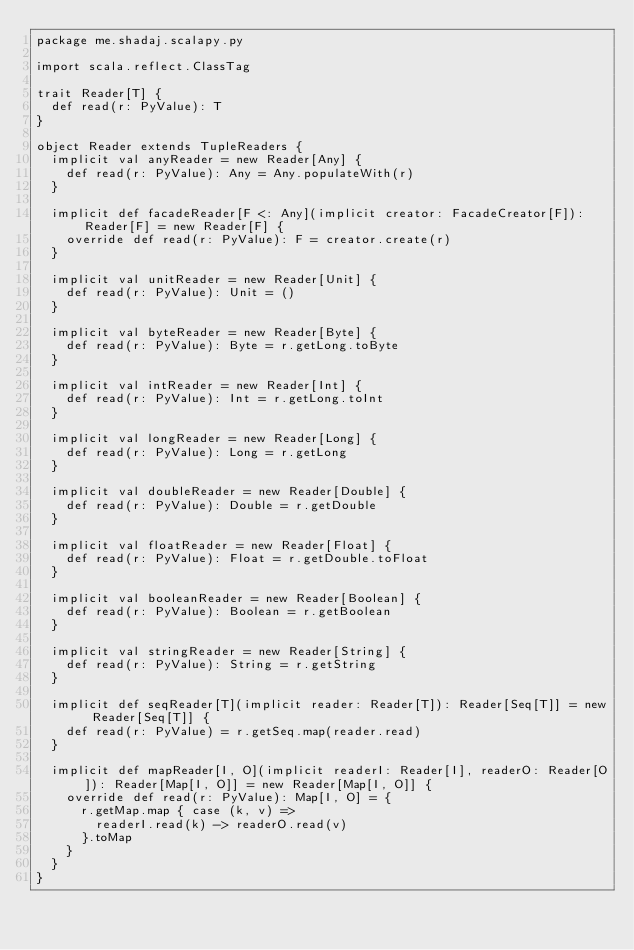<code> <loc_0><loc_0><loc_500><loc_500><_Scala_>package me.shadaj.scalapy.py

import scala.reflect.ClassTag

trait Reader[T] {
  def read(r: PyValue): T
}

object Reader extends TupleReaders {
  implicit val anyReader = new Reader[Any] {
    def read(r: PyValue): Any = Any.populateWith(r)
  }

  implicit def facadeReader[F <: Any](implicit creator: FacadeCreator[F]): Reader[F] = new Reader[F] {
    override def read(r: PyValue): F = creator.create(r)
  }

  implicit val unitReader = new Reader[Unit] {
    def read(r: PyValue): Unit = ()
  }

  implicit val byteReader = new Reader[Byte] {
    def read(r: PyValue): Byte = r.getLong.toByte
  }

  implicit val intReader = new Reader[Int] {
    def read(r: PyValue): Int = r.getLong.toInt
  }

  implicit val longReader = new Reader[Long] {
    def read(r: PyValue): Long = r.getLong
  }

  implicit val doubleReader = new Reader[Double] {
    def read(r: PyValue): Double = r.getDouble
  }

  implicit val floatReader = new Reader[Float] {
    def read(r: PyValue): Float = r.getDouble.toFloat
  }

  implicit val booleanReader = new Reader[Boolean] {
    def read(r: PyValue): Boolean = r.getBoolean
  }

  implicit val stringReader = new Reader[String] {
    def read(r: PyValue): String = r.getString
  }

  implicit def seqReader[T](implicit reader: Reader[T]): Reader[Seq[T]] = new Reader[Seq[T]] {
    def read(r: PyValue) = r.getSeq.map(reader.read)
  }

  implicit def mapReader[I, O](implicit readerI: Reader[I], readerO: Reader[O]): Reader[Map[I, O]] = new Reader[Map[I, O]] {
    override def read(r: PyValue): Map[I, O] = {
      r.getMap.map { case (k, v) =>
        readerI.read(k) -> readerO.read(v)
      }.toMap
    }
  }
}
</code> 